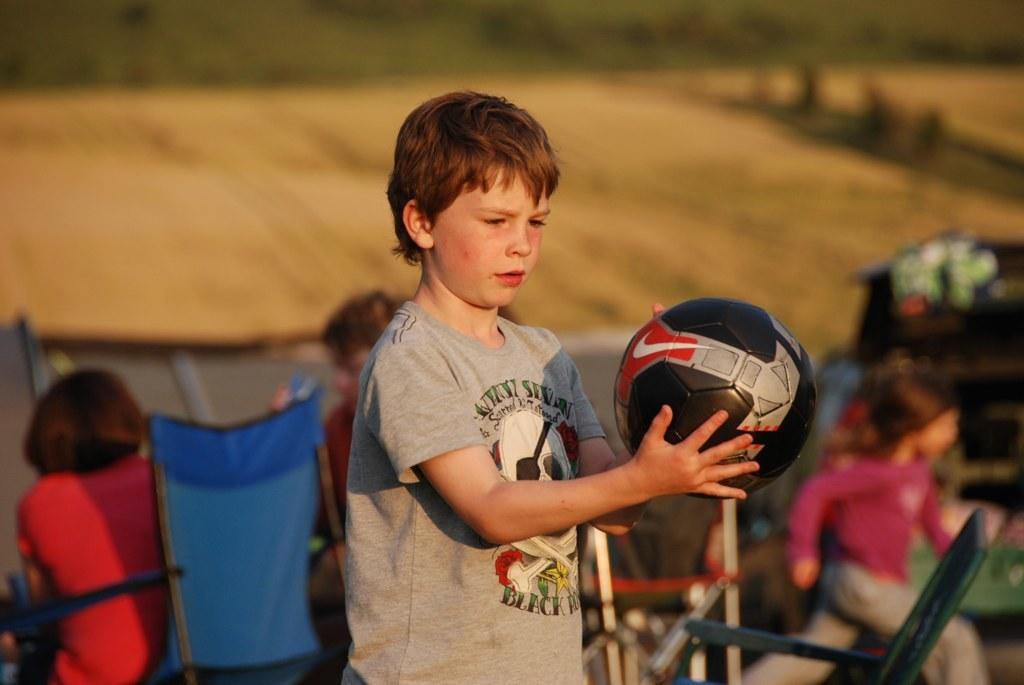Who is the main subject in the image? There is a boy in the center of the image. What is the boy holding in the image? The boy is holding a football. What can be seen in the background of the image? There are people sitting on chairs in the background. What is the girl doing at the right side of the image? There is a girl running at the right side of the image. What type of whip can be seen in the hands of the boy in the image? There is no whip present in the image; the boy is holding a football. How many snails can be seen crawling on the football in the image? There are no snails present in the image; the boy is holding a football. 